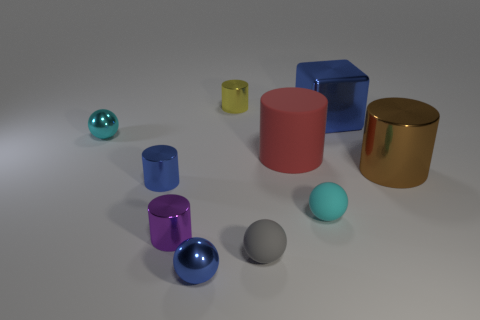Can you tell me what the different colors are for the objects in the scene? Certainly! There are objects in various colors: metallic shades on the spheres, blue and red for the cubes, a pink cylinder, a yellow smaller cylinder, and a gold-colored cylinder. 